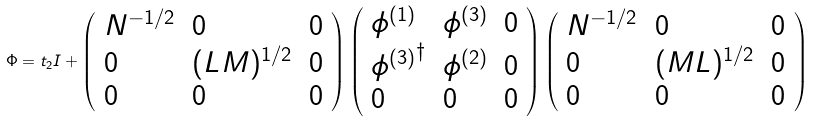Convert formula to latex. <formula><loc_0><loc_0><loc_500><loc_500>\Phi = t _ { 2 } I + \left ( \begin{array} { l l l } { { N ^ { - 1 / 2 } } } & { 0 } & { 0 } \\ { 0 } & { { ( L M ) ^ { 1 / 2 } } } & { 0 } \\ { 0 } & { 0 } & { 0 } \end{array} \right ) \left ( \begin{array} { l l l } { { \phi ^ { ( 1 ) } } } & { { \phi ^ { ( 3 ) } } } & { 0 } \\ { { { \phi ^ { ( 3 ) } } ^ { \dagger } } } & { { \phi ^ { ( 2 ) } } } & { 0 } \\ { 0 } & { 0 } & { 0 } \end{array} \right ) \left ( \begin{array} { l l l } { { N ^ { - 1 / 2 } } } & { 0 } & { 0 } \\ { 0 } & { { ( M L ) ^ { 1 / 2 } } } & { 0 } \\ { 0 } & { 0 } & { 0 } \end{array} \right )</formula> 